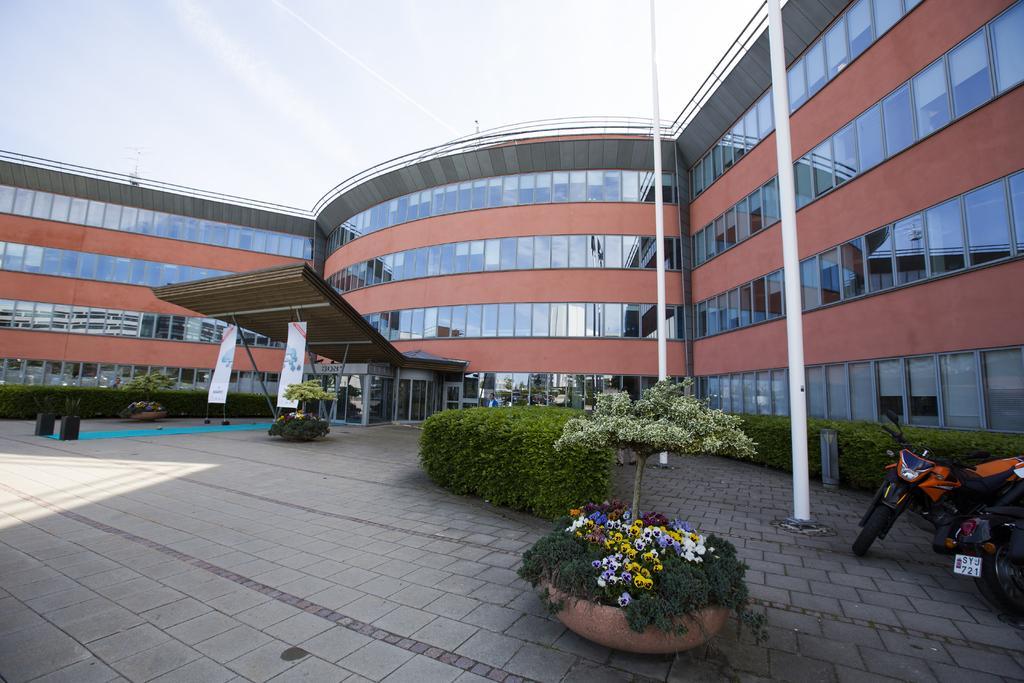Describe this image in one or two sentences. At the bottom I can see few plants and a flower pot on the ground. In the flower pot I can see many flowers which are in different colors. On the right side there are two bikes on the ground. In the background there is a building and I can see two poles. At the top I can see the sky. 